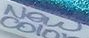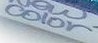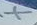Read the text content from these images in order, separated by a semicolon. New; color; X 